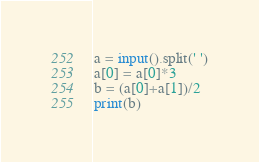<code> <loc_0><loc_0><loc_500><loc_500><_Python_>a = input().split(' ')
a[0] = a[0]*3
b = (a[0]+a[1])/2
print(b)</code> 